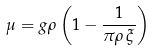<formula> <loc_0><loc_0><loc_500><loc_500>\mu = g \rho \left ( 1 - \frac { 1 } { \pi \rho \, \xi } \right )</formula> 